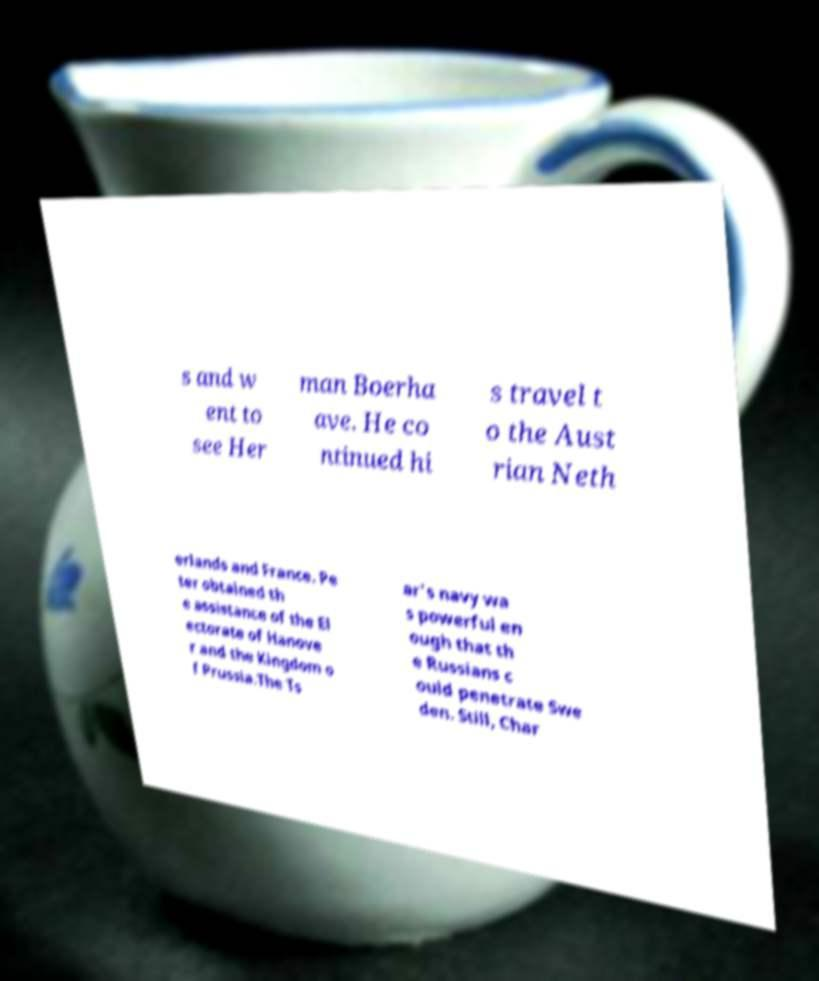There's text embedded in this image that I need extracted. Can you transcribe it verbatim? s and w ent to see Her man Boerha ave. He co ntinued hi s travel t o the Aust rian Neth erlands and France. Pe ter obtained th e assistance of the El ectorate of Hanove r and the Kingdom o f Prussia.The Ts ar's navy wa s powerful en ough that th e Russians c ould penetrate Swe den. Still, Char 